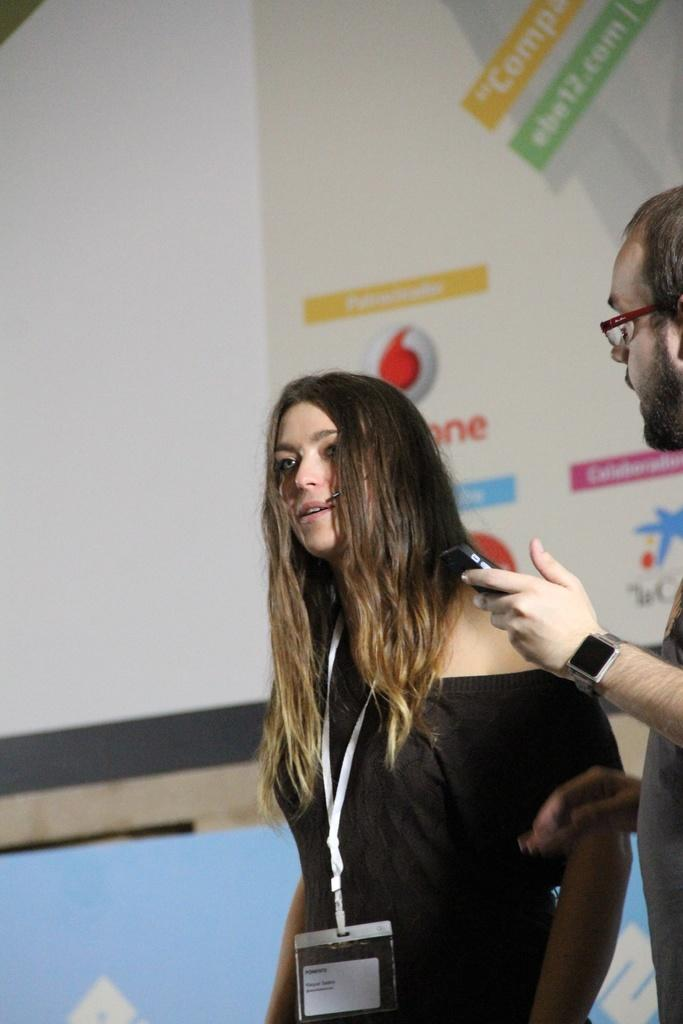How many people are in the image? There are a few people in the image. What can be seen in the background of the image? There are boards with text and images in the background of the image. What is the price of the turkey in the image? There is no turkey present in the image, so it is not possible to determine its price. 